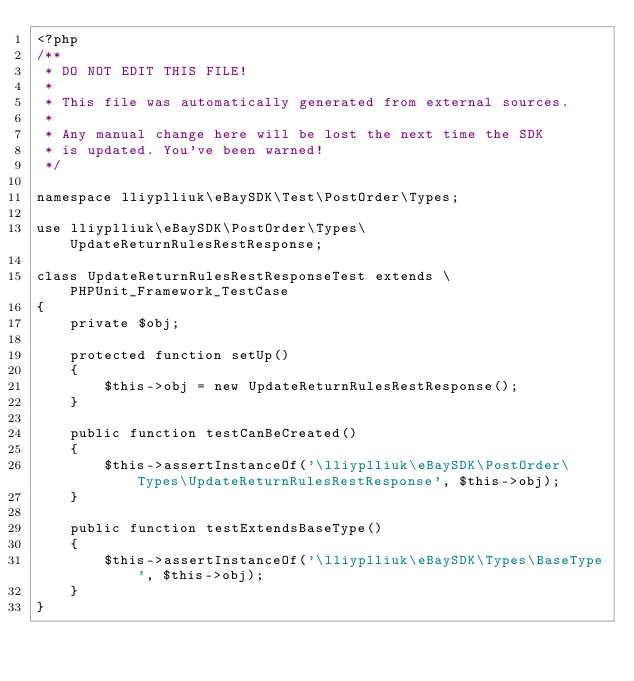<code> <loc_0><loc_0><loc_500><loc_500><_PHP_><?php
/**
 * DO NOT EDIT THIS FILE!
 *
 * This file was automatically generated from external sources.
 *
 * Any manual change here will be lost the next time the SDK
 * is updated. You've been warned!
 */

namespace lliyplliuk\eBaySDK\Test\PostOrder\Types;

use lliyplliuk\eBaySDK\PostOrder\Types\UpdateReturnRulesRestResponse;

class UpdateReturnRulesRestResponseTest extends \PHPUnit_Framework_TestCase
{
    private $obj;

    protected function setUp()
    {
        $this->obj = new UpdateReturnRulesRestResponse();
    }

    public function testCanBeCreated()
    {
        $this->assertInstanceOf('\lliyplliuk\eBaySDK\PostOrder\Types\UpdateReturnRulesRestResponse', $this->obj);
    }

    public function testExtendsBaseType()
    {
        $this->assertInstanceOf('\lliyplliuk\eBaySDK\Types\BaseType', $this->obj);
    }
}
</code> 